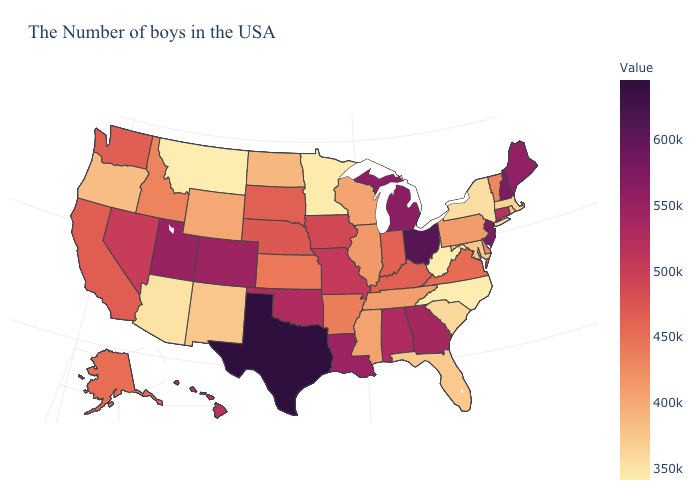Which states hav the highest value in the Northeast?
Answer briefly. New Jersey. Which states have the lowest value in the USA?
Give a very brief answer. North Carolina, West Virginia, Montana. 